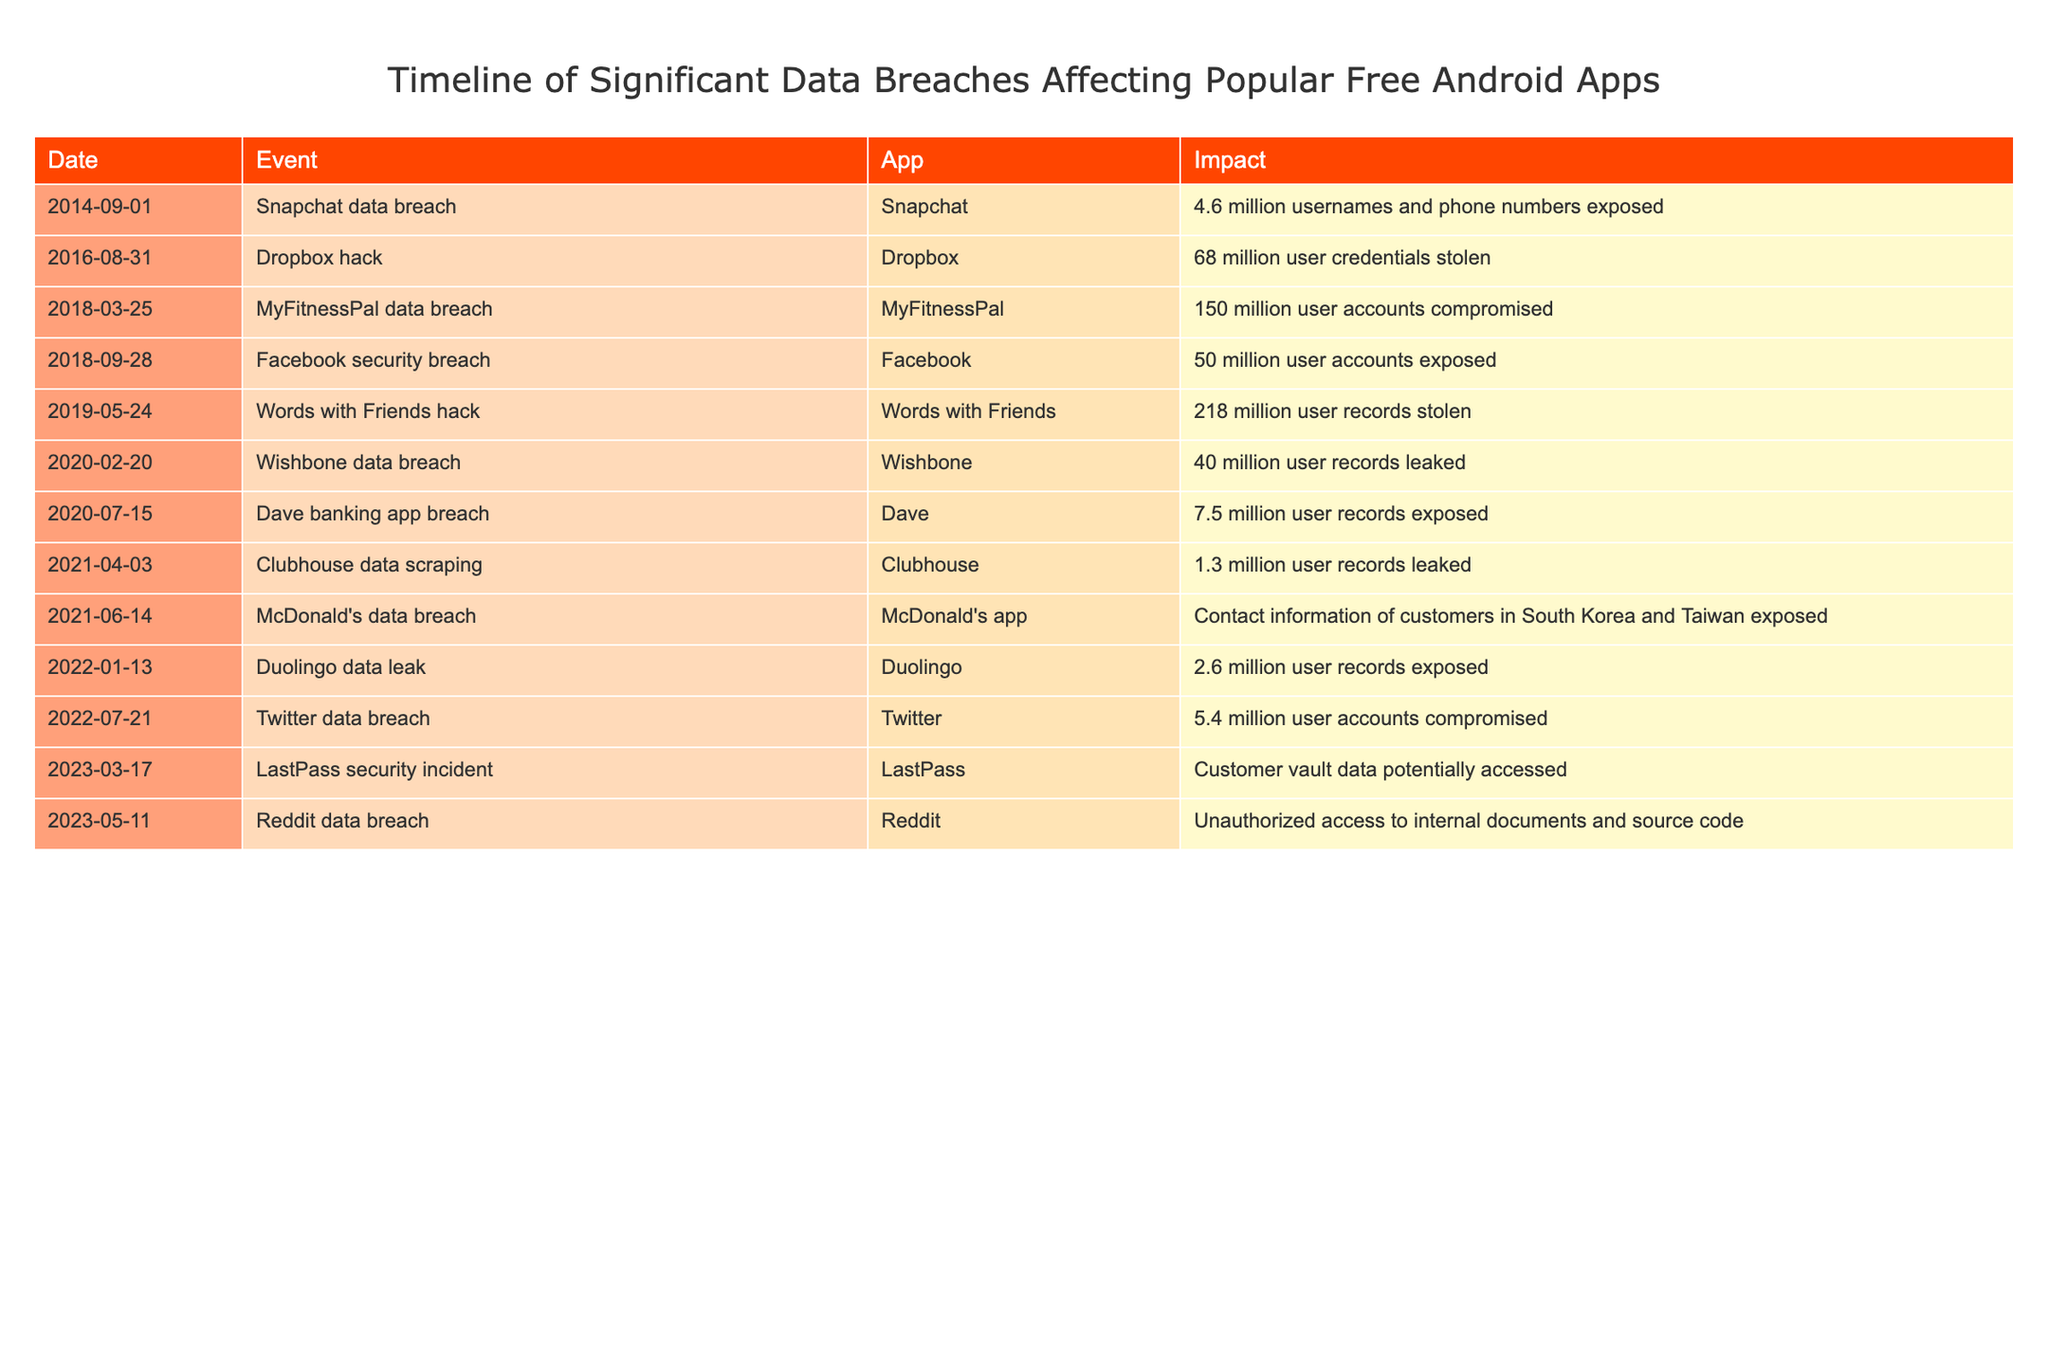What was the date of the MyFitnessPal data breach? The table lists the event details, including the date when the MyFitnessPal data breach occurred. By checking the row for MyFitnessPal, we find that the date is March 25, 2018.
Answer: March 25, 2018 How many user accounts were compromised in the Facebook security breach? Looking at the row for the Facebook security breach, we see that it involved 50 million user accounts. This is a direct reference from the impact column for that event.
Answer: 50 million Which app experienced the most significant data breach in terms of the number of records impacted? To find this, we need to look at the impact values for all the breaches and compare them. The Words with Friends hack indicates 218 million user records stolen, which is the highest compared to others in the table.
Answer: Words with Friends Did the Duolingo data leak occur before or after the Dropbox hack? The Duolingo data leak happened on January 13, 2022, and the Dropbox hack occurred on August 31, 2016. Comparing these two dates shows that the Duolingo leak occurred after the Dropbox hack.
Answer: After What is the total number of user records exposed in the data breaches listed in 2020? For 2020, we have the Wishbone data breach (40 million) and the Dave banking app breach (7.5 million). Adding these gives us a total: 40 million + 7.5 million = 47.5 million.
Answer: 47.5 million Is it true that there were any data breaches affecting apps in 2021? By examining the events listed in 2021, we see that there were two breaches: the Clubhouse data scraping and the McDonald's data breach. Hence, there were indeed breaches affecting apps in 2021.
Answer: Yes What was the year with the second most significant number of breaches reported? By reviewing the years listed in the data breaches, we find there are three in 2020, two in 2018, two in 2021, two in 2022, and two in 2023. The year with the most is 2020, and the second most significant would be the years with two reported breaches: 2018, 2021, 2022, and 2023. Therefore, the answer is any of these years.
Answer: 2018, 2021, 2022, or 2023 What app had a data breach with customer information exposed in South Korea and Taiwan? The table specifies that the McDonald's app had data breach incidents affecting customer contact information specifically in South Korea and Taiwan. This is a direct correlation found in the app column.
Answer: McDonald's app 